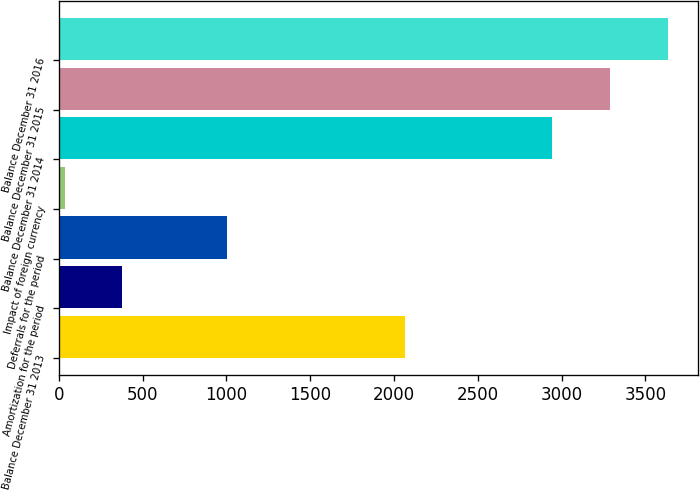Convert chart. <chart><loc_0><loc_0><loc_500><loc_500><bar_chart><fcel>Balance December 31 2013<fcel>Amortization for the period<fcel>Deferrals for the period<fcel>Impact of foreign currency<fcel>Balance December 31 2014<fcel>Balance December 31 2015<fcel>Balance December 31 2016<nl><fcel>2065<fcel>378.7<fcel>1001<fcel>34<fcel>2946<fcel>3290.7<fcel>3635.4<nl></chart> 